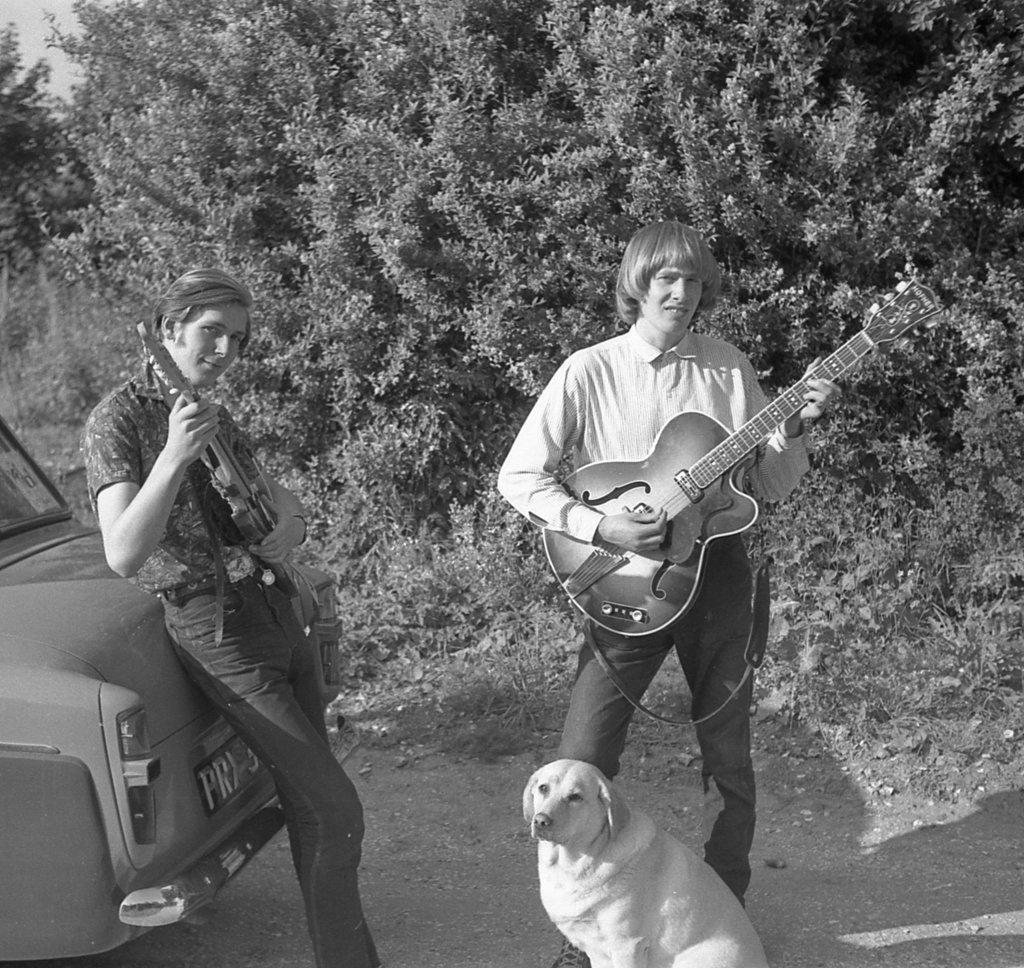Could you give a brief overview of what you see in this image? In the image we can see two persons were holding guitar. And on the left side we can see the car. In bottom we can see dog. Back of them we can see trees. 